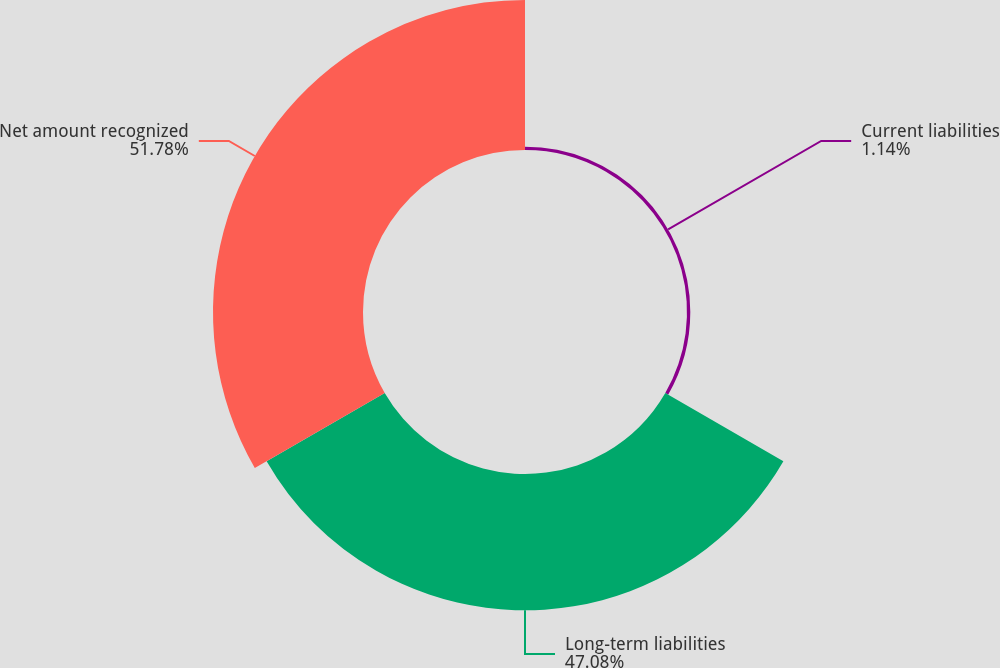Convert chart. <chart><loc_0><loc_0><loc_500><loc_500><pie_chart><fcel>Current liabilities<fcel>Long-term liabilities<fcel>Net amount recognized<nl><fcel>1.14%<fcel>47.08%<fcel>51.79%<nl></chart> 